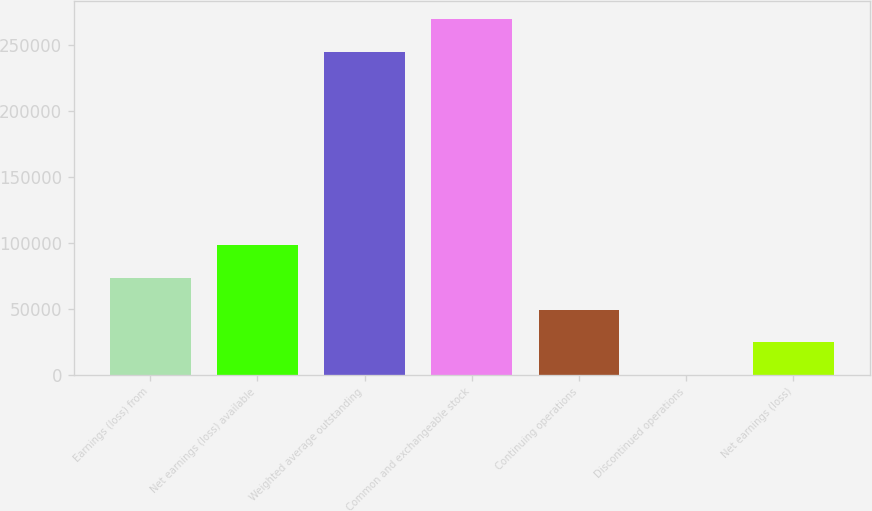Convert chart to OTSL. <chart><loc_0><loc_0><loc_500><loc_500><bar_chart><fcel>Earnings (loss) from<fcel>Net earnings (loss) available<fcel>Weighted average outstanding<fcel>Common and exchangeable stock<fcel>Continuing operations<fcel>Discontinued operations<fcel>Net earnings (loss)<nl><fcel>73735.1<fcel>98313<fcel>244931<fcel>269509<fcel>49157.3<fcel>1.6<fcel>24579.4<nl></chart> 